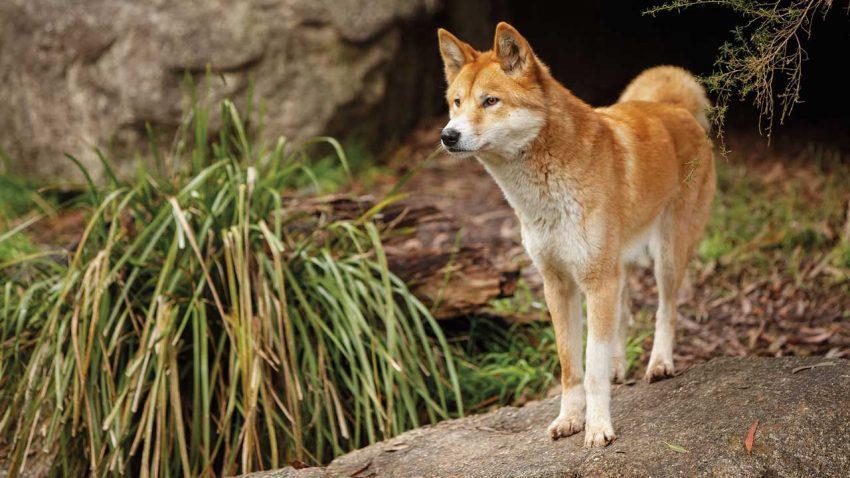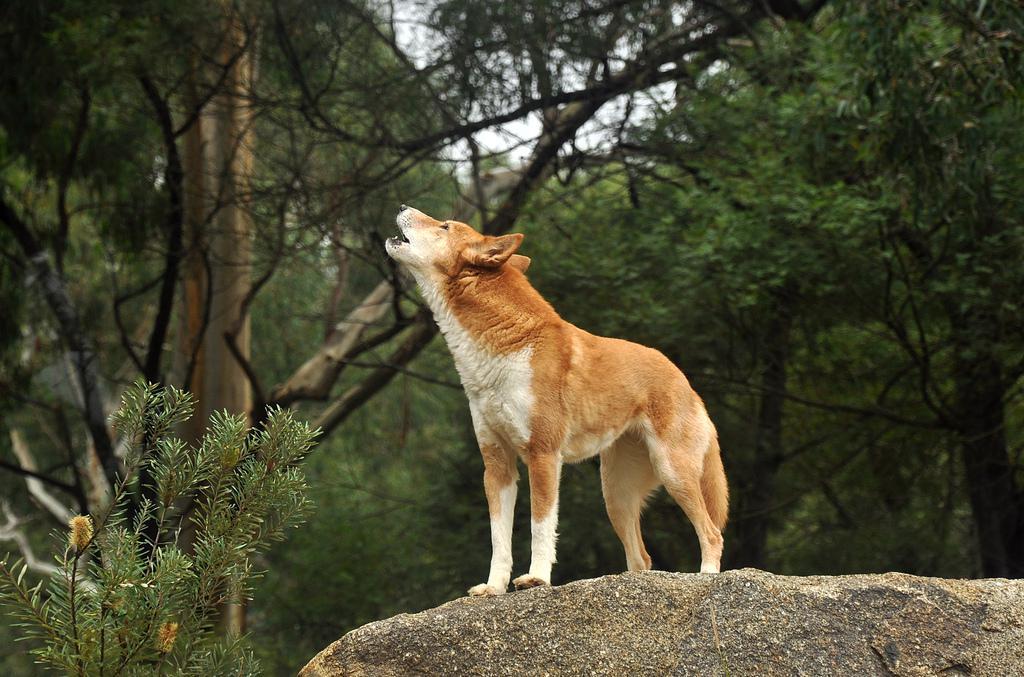The first image is the image on the left, the second image is the image on the right. Assess this claim about the two images: "There's no more than one wild dog in the right image.". Correct or not? Answer yes or no. Yes. The first image is the image on the left, the second image is the image on the right. For the images displayed, is the sentence "There are more animals in the left image than there are in the right image." factually correct? Answer yes or no. No. 